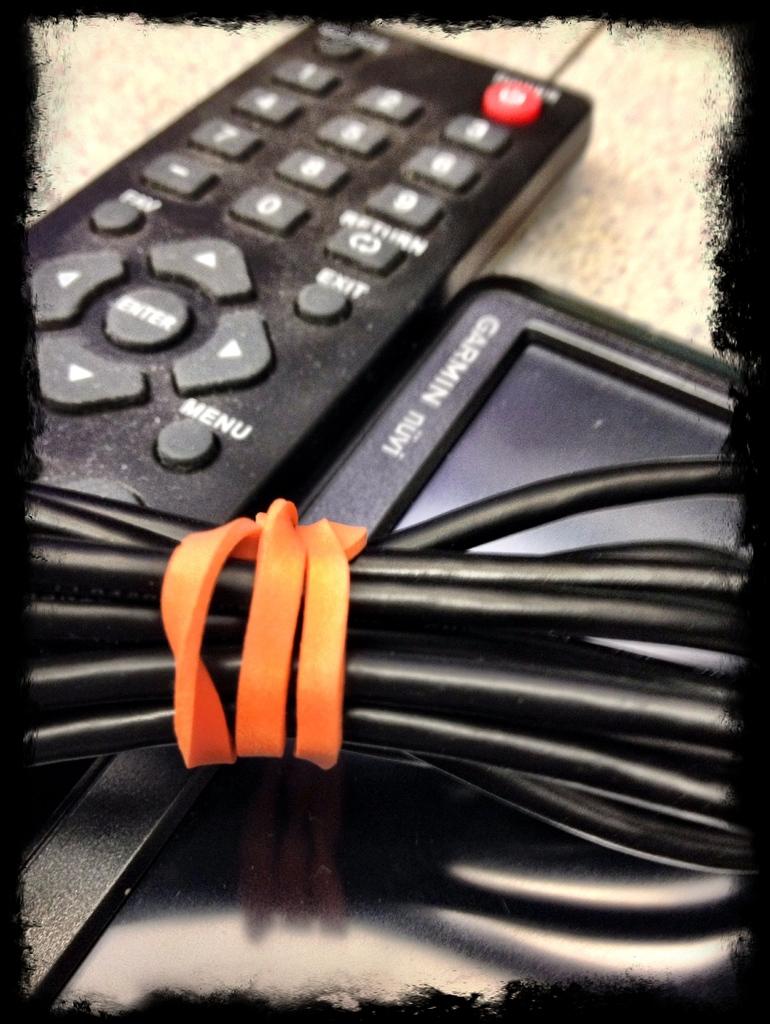What gps device is this?
Your answer should be very brief. Garmin. Is it called a mini?
Provide a short and direct response. Yes. 